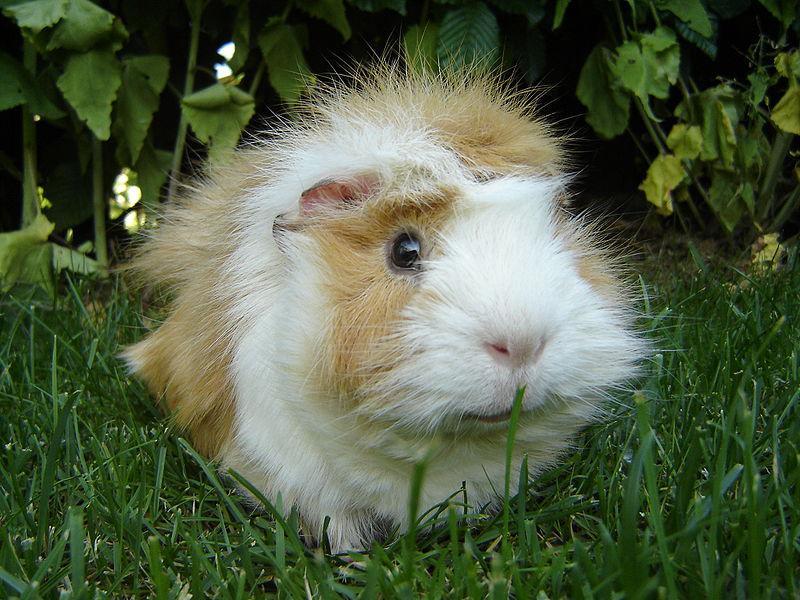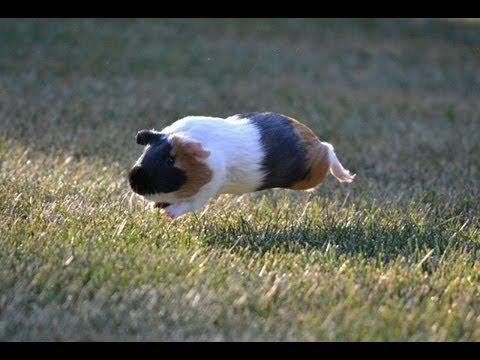The first image is the image on the left, the second image is the image on the right. For the images displayed, is the sentence "There are two guinea pigs on the ground in the image on the right." factually correct? Answer yes or no. No. 